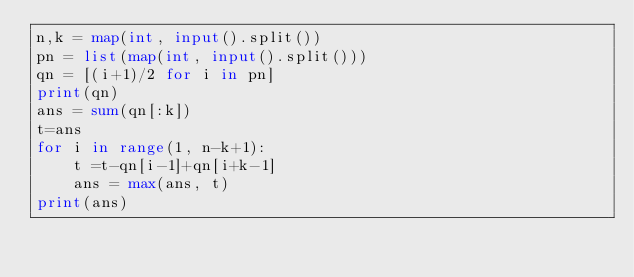Convert code to text. <code><loc_0><loc_0><loc_500><loc_500><_Python_>n,k = map(int, input().split())
pn = list(map(int, input().split()))
qn = [(i+1)/2 for i in pn]
print(qn)
ans = sum(qn[:k])
t=ans
for i in range(1, n-k+1):
    t =t-qn[i-1]+qn[i+k-1]
    ans = max(ans, t)
print(ans)</code> 